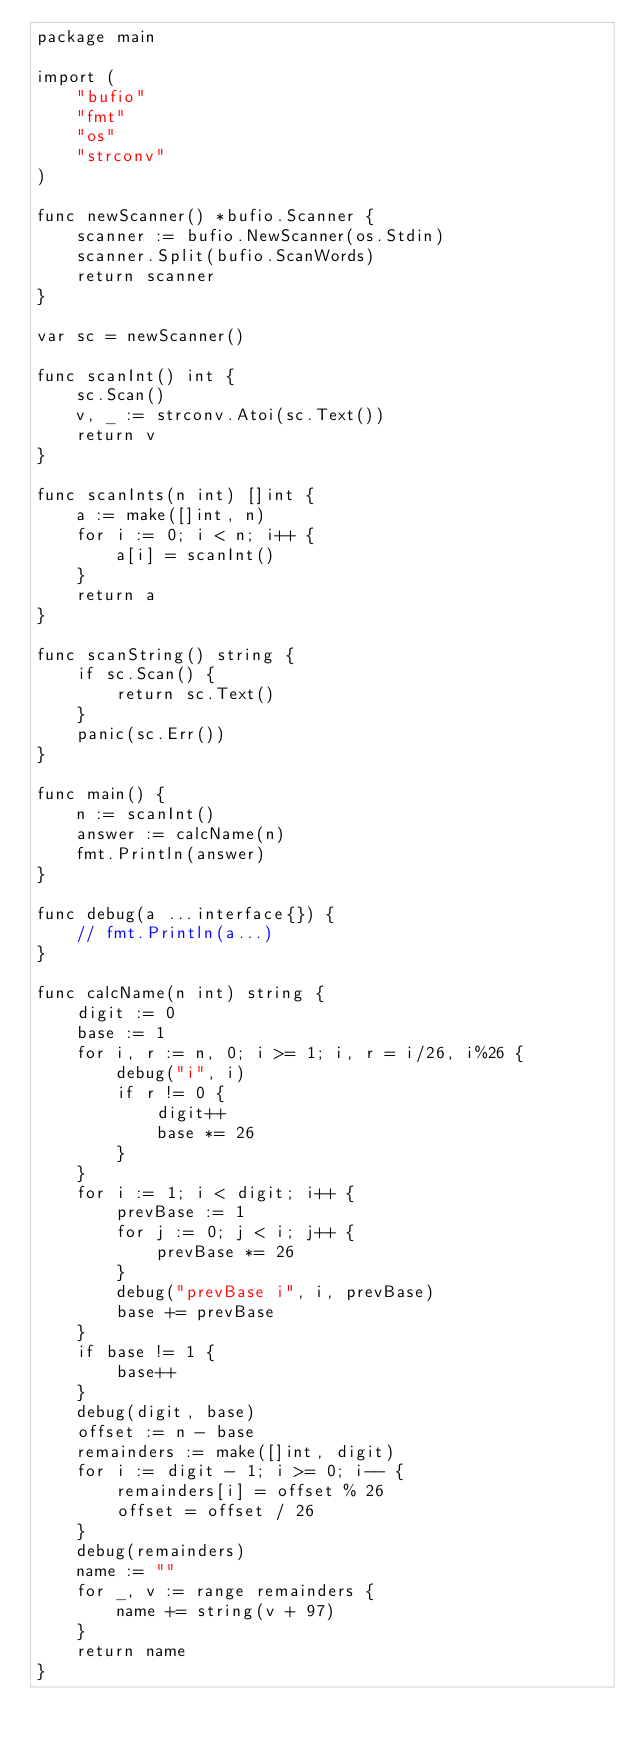<code> <loc_0><loc_0><loc_500><loc_500><_Go_>package main

import (
	"bufio"
	"fmt"
	"os"
	"strconv"
)

func newScanner() *bufio.Scanner {
	scanner := bufio.NewScanner(os.Stdin)
	scanner.Split(bufio.ScanWords)
	return scanner
}

var sc = newScanner()

func scanInt() int {
	sc.Scan()
	v, _ := strconv.Atoi(sc.Text())
	return v
}

func scanInts(n int) []int {
	a := make([]int, n)
	for i := 0; i < n; i++ {
		a[i] = scanInt()
	}
	return a
}

func scanString() string {
	if sc.Scan() {
		return sc.Text()
	}
	panic(sc.Err())
}

func main() {
	n := scanInt()
	answer := calcName(n)
	fmt.Println(answer)
}

func debug(a ...interface{}) {
	// fmt.Println(a...)
}

func calcName(n int) string {
	digit := 0
	base := 1
	for i, r := n, 0; i >= 1; i, r = i/26, i%26 {
		debug("i", i)
		if r != 0 {
			digit++
			base *= 26
		}
	}
	for i := 1; i < digit; i++ {
		prevBase := 1
		for j := 0; j < i; j++ {
			prevBase *= 26
		}
		debug("prevBase i", i, prevBase)
		base += prevBase
	}
	if base != 1 {
		base++
	}
	debug(digit, base)
	offset := n - base
	remainders := make([]int, digit)
	for i := digit - 1; i >= 0; i-- {
		remainders[i] = offset % 26
		offset = offset / 26
	}
	debug(remainders)
	name := ""
	for _, v := range remainders {
		name += string(v + 97)
	}
	return name
}
</code> 